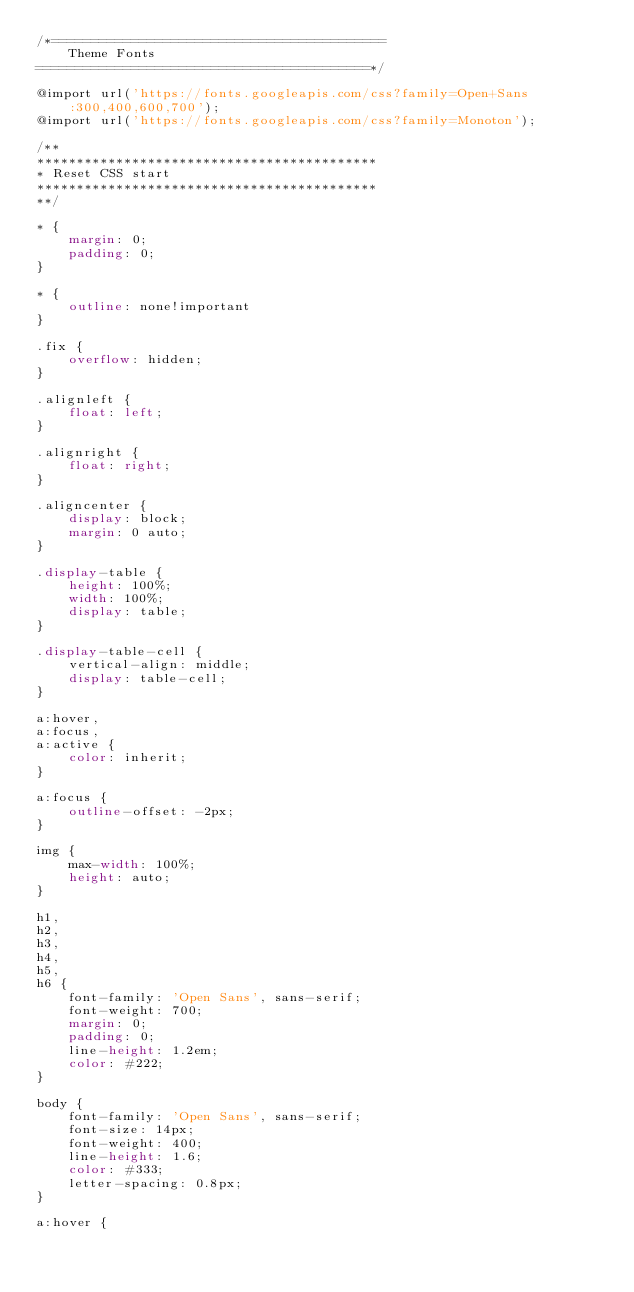Convert code to text. <code><loc_0><loc_0><loc_500><loc_500><_CSS_>/*==========================================
    Theme Fonts
==========================================*/

@import url('https://fonts.googleapis.com/css?family=Open+Sans:300,400,600,700');
@import url('https://fonts.googleapis.com/css?family=Monoton');

/**
*******************************************
* Reset CSS start
*******************************************
**/

* {
    margin: 0;
    padding: 0;
}

* {
    outline: none!important
}

.fix {
    overflow: hidden;
}

.alignleft {
    float: left;
}

.alignright {
    float: right;
}

.aligncenter {
    display: block;
    margin: 0 auto;
}

.display-table {
    height: 100%;
    width: 100%;
    display: table;
}

.display-table-cell {
    vertical-align: middle;
    display: table-cell;
}

a:hover,
a:focus,
a:active {
    color: inherit;
}

a:focus {
    outline-offset: -2px;
}

img {
    max-width: 100%;
    height: auto;
}

h1,
h2,
h3,
h4,
h5,
h6 {
    font-family: 'Open Sans', sans-serif;
    font-weight: 700;
    margin: 0;
    padding: 0;
    line-height: 1.2em;
    color: #222;
}

body {
    font-family: 'Open Sans', sans-serif;
    font-size: 14px;
    font-weight: 400;
    line-height: 1.6;
    color: #333;
    letter-spacing: 0.8px;
}

a:hover {</code> 